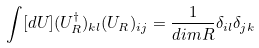<formula> <loc_0><loc_0><loc_500><loc_500>\int [ d U ] ( U _ { R } ^ { \dagger } ) _ { k l } ( U _ { R } ) _ { i j } = \frac { 1 } { d i m R } \delta _ { i l } \delta _ { j k }</formula> 